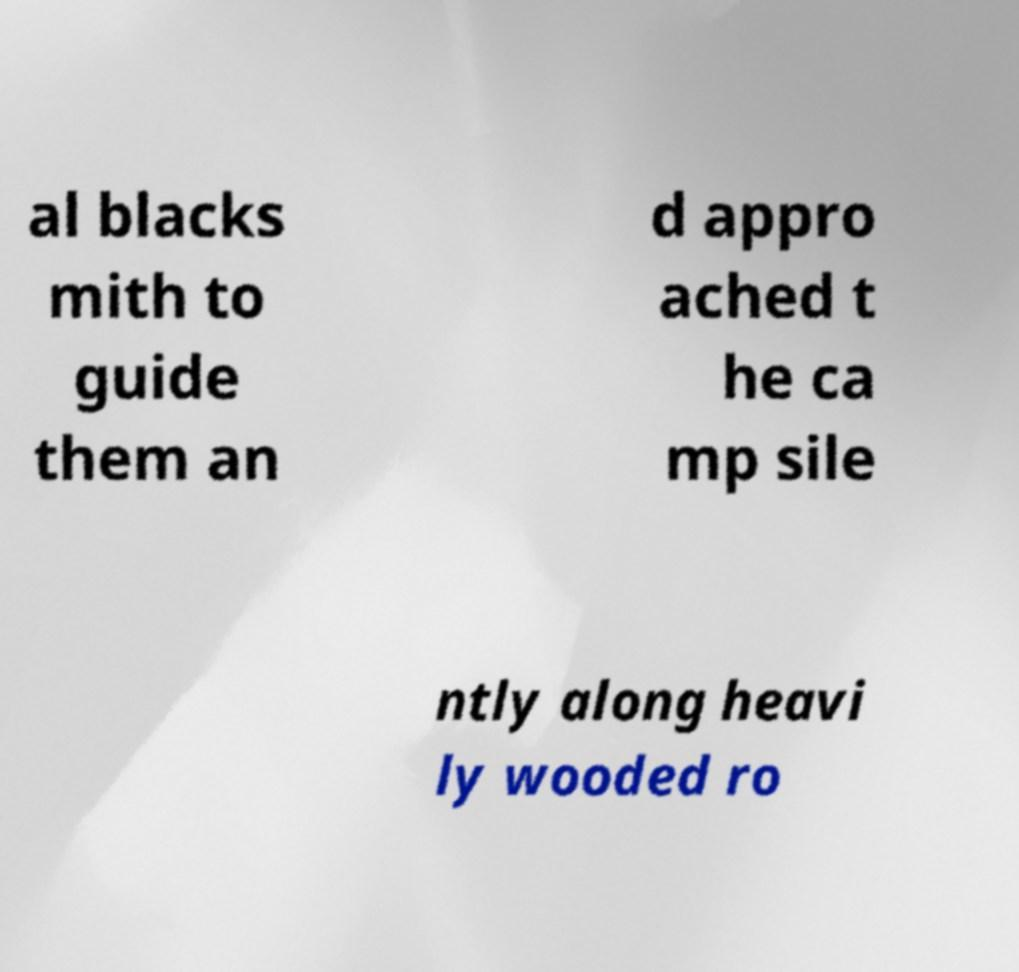Please read and relay the text visible in this image. What does it say? al blacks mith to guide them an d appro ached t he ca mp sile ntly along heavi ly wooded ro 